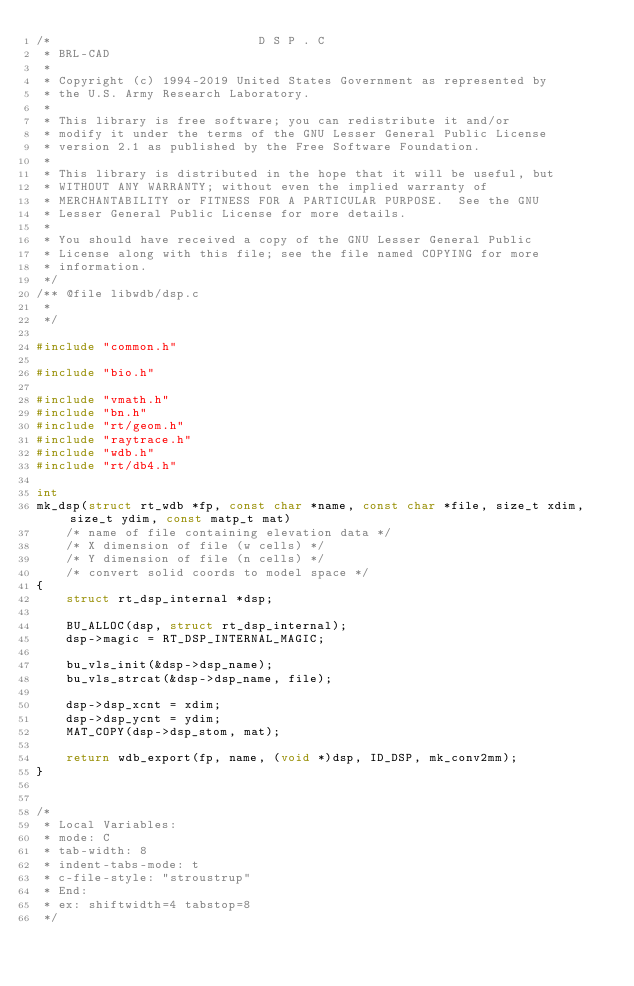Convert code to text. <code><loc_0><loc_0><loc_500><loc_500><_C_>/*                            D S P . C
 * BRL-CAD
 *
 * Copyright (c) 1994-2019 United States Government as represented by
 * the U.S. Army Research Laboratory.
 *
 * This library is free software; you can redistribute it and/or
 * modify it under the terms of the GNU Lesser General Public License
 * version 2.1 as published by the Free Software Foundation.
 *
 * This library is distributed in the hope that it will be useful, but
 * WITHOUT ANY WARRANTY; without even the implied warranty of
 * MERCHANTABILITY or FITNESS FOR A PARTICULAR PURPOSE.  See the GNU
 * Lesser General Public License for more details.
 *
 * You should have received a copy of the GNU Lesser General Public
 * License along with this file; see the file named COPYING for more
 * information.
 */
/** @file libwdb/dsp.c
 *
 */

#include "common.h"

#include "bio.h"

#include "vmath.h"
#include "bn.h"
#include "rt/geom.h"
#include "raytrace.h"
#include "wdb.h"
#include "rt/db4.h"

int
mk_dsp(struct rt_wdb *fp, const char *name, const char *file, size_t xdim, size_t ydim, const matp_t mat)
    /* name of file containing elevation data */
    /* X dimension of file (w cells) */
    /* Y dimension of file (n cells) */
    /* convert solid coords to model space */
{
    struct rt_dsp_internal *dsp;

    BU_ALLOC(dsp, struct rt_dsp_internal);
    dsp->magic = RT_DSP_INTERNAL_MAGIC;

    bu_vls_init(&dsp->dsp_name);
    bu_vls_strcat(&dsp->dsp_name, file);

    dsp->dsp_xcnt = xdim;
    dsp->dsp_ycnt = ydim;
    MAT_COPY(dsp->dsp_stom, mat);

    return wdb_export(fp, name, (void *)dsp, ID_DSP, mk_conv2mm);
}


/*
 * Local Variables:
 * mode: C
 * tab-width: 8
 * indent-tabs-mode: t
 * c-file-style: "stroustrup"
 * End:
 * ex: shiftwidth=4 tabstop=8
 */
</code> 